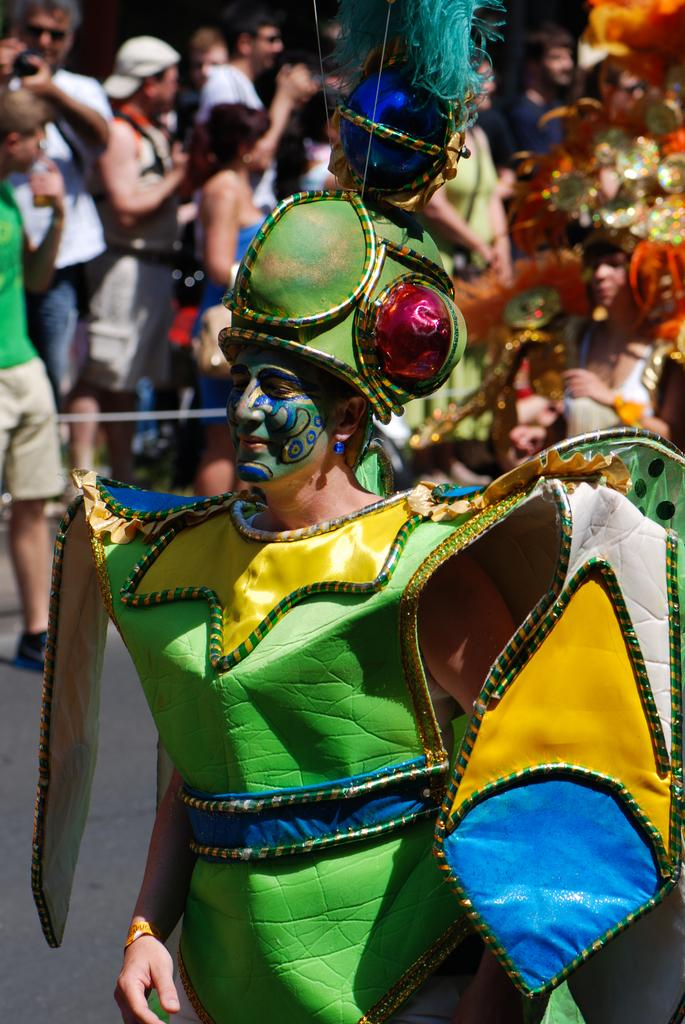Who or what is the main subject of the image? There is a person in the image. Can you describe the surrounding environment in the image? There are other persons and objects in the background of the image. What type of account is being discussed in the image? There is no mention of an account in the image; it features a person and other persons and objects in the background. 